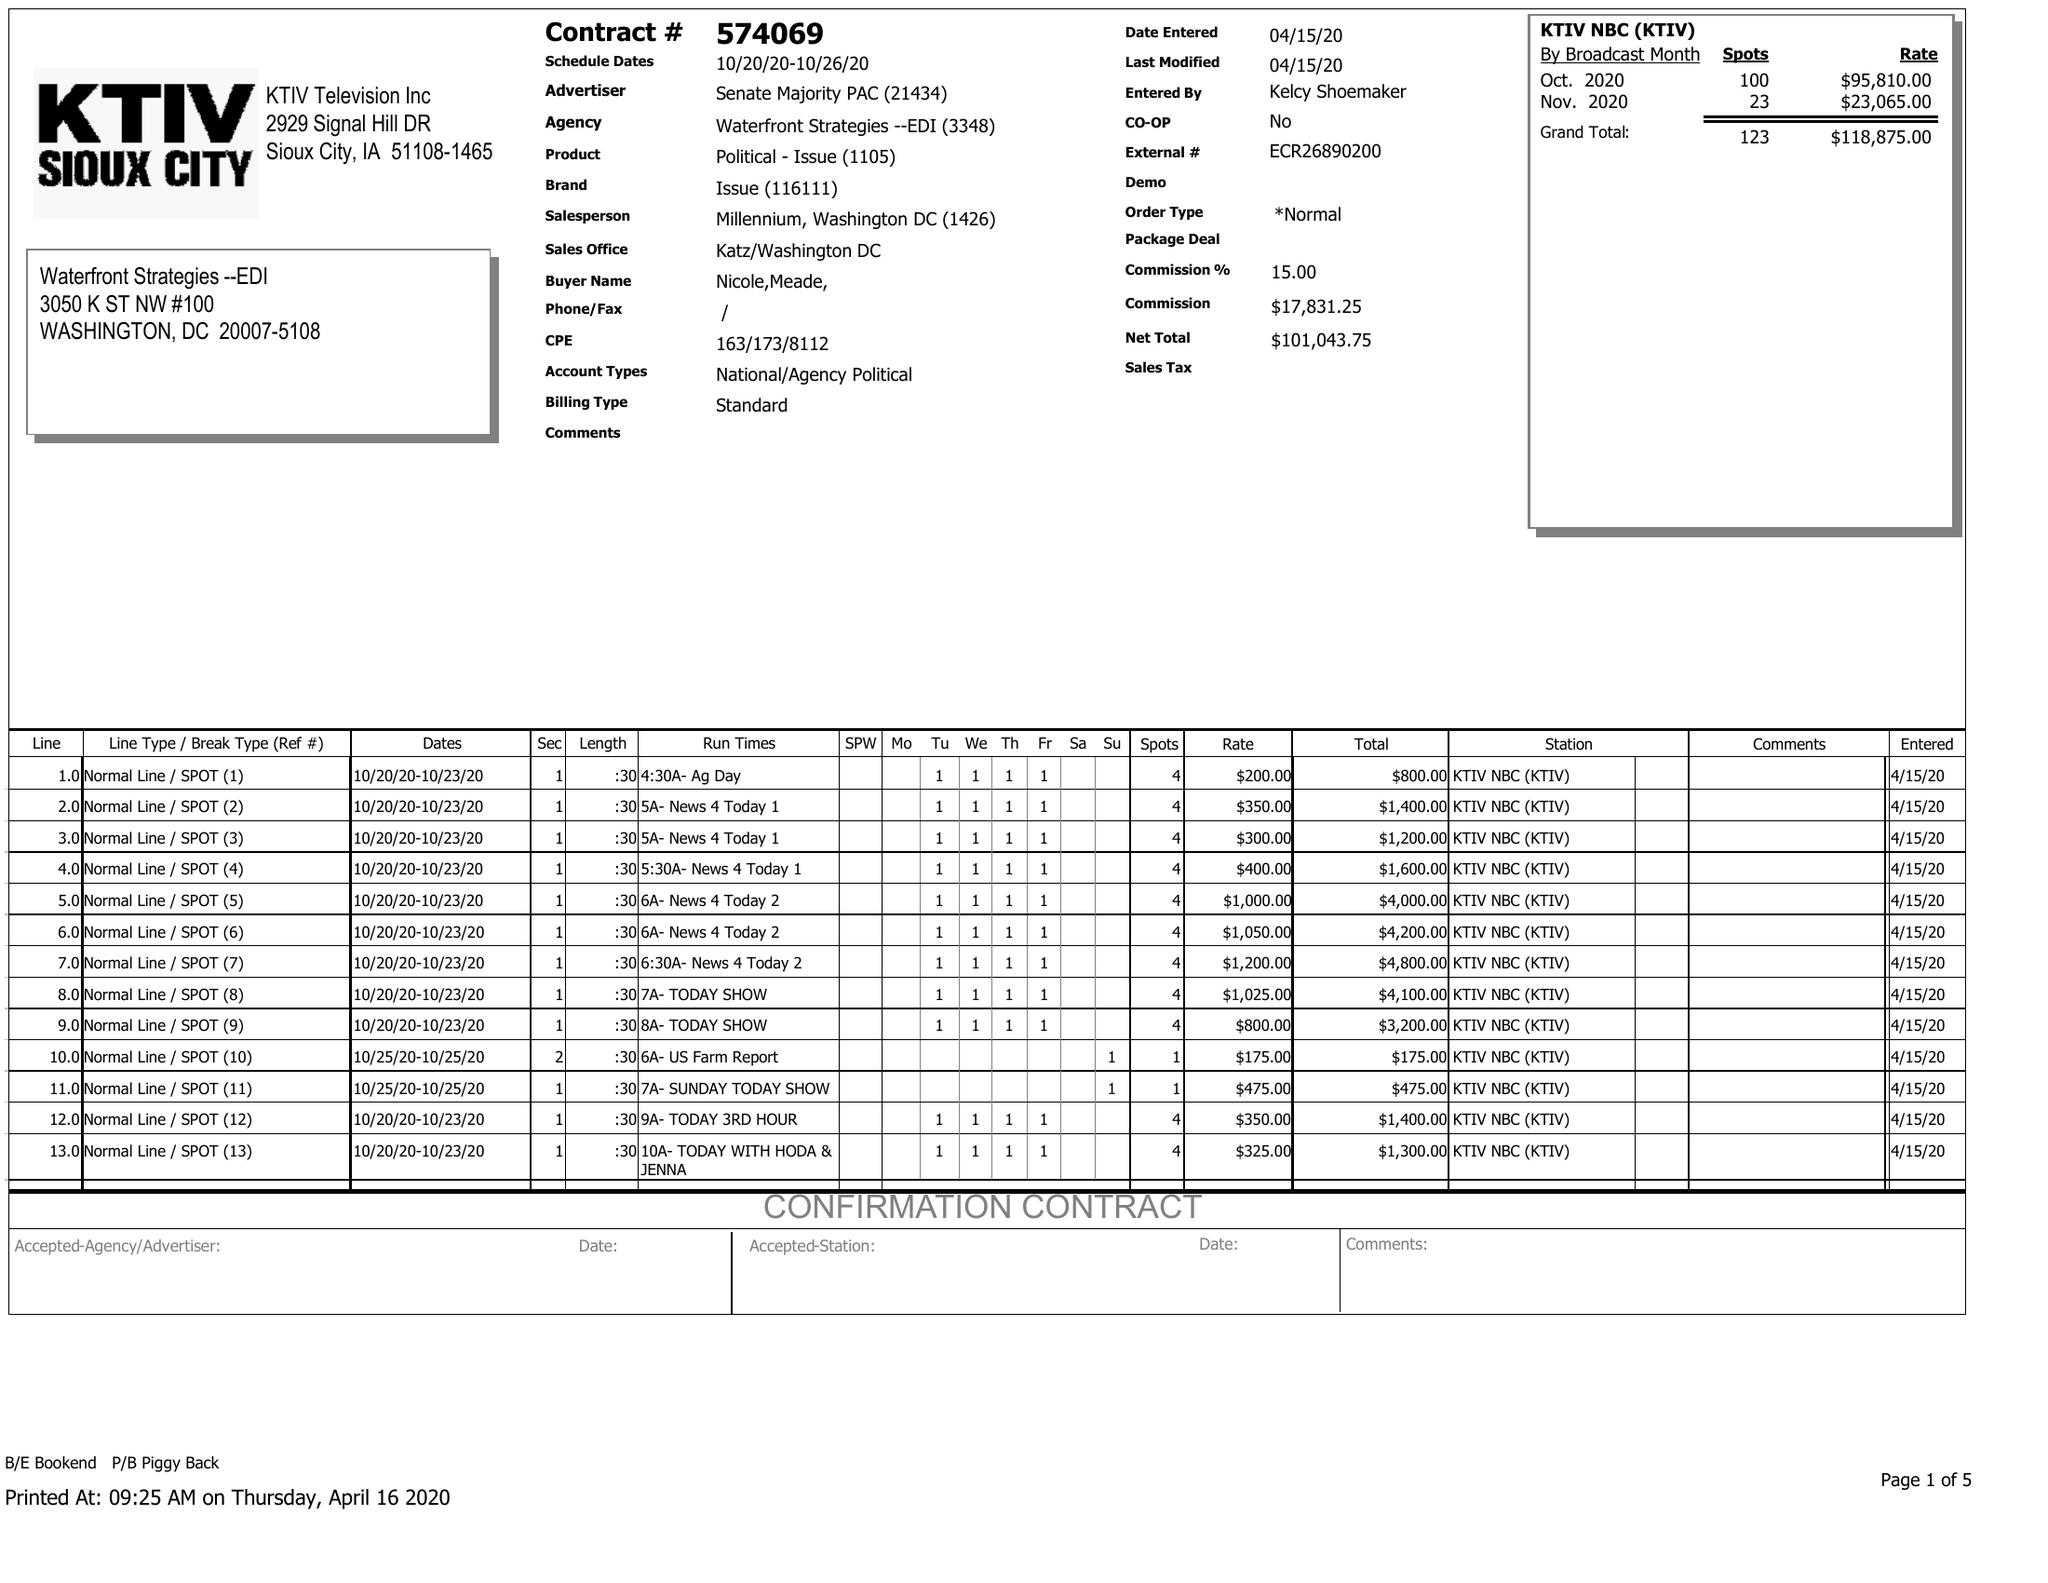What is the value for the flight_to?
Answer the question using a single word or phrase. 10/26/20 